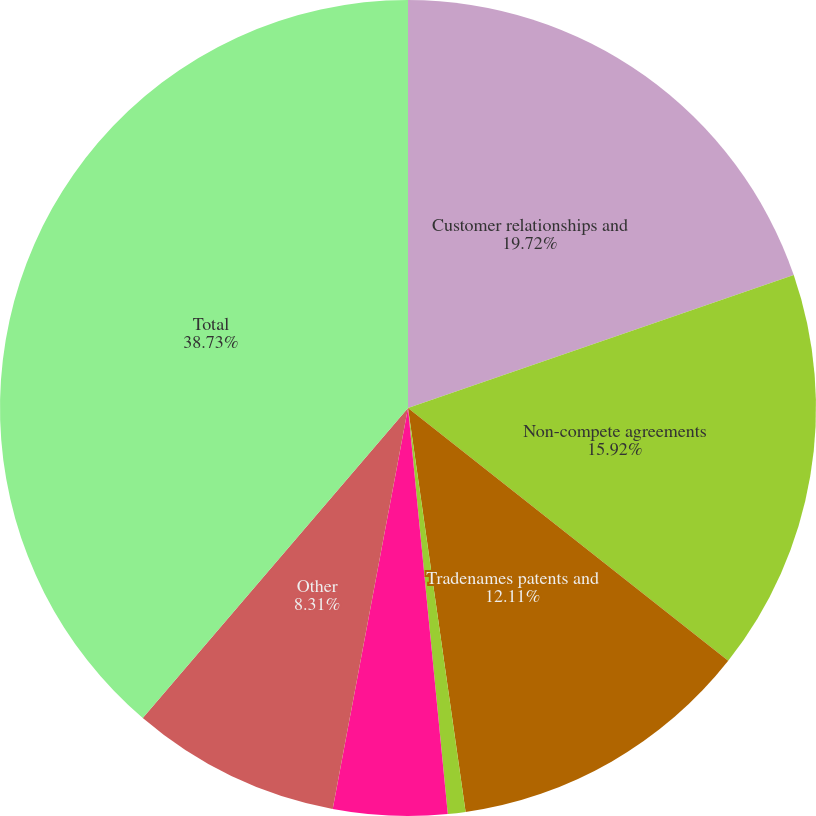<chart> <loc_0><loc_0><loc_500><loc_500><pie_chart><fcel>Customer relationships and<fcel>Non-compete agreements<fcel>Tradenames patents and<fcel>Land and water rights<fcel>Software<fcel>Other<fcel>Total<nl><fcel>19.72%<fcel>15.92%<fcel>12.11%<fcel>0.7%<fcel>4.51%<fcel>8.31%<fcel>38.74%<nl></chart> 